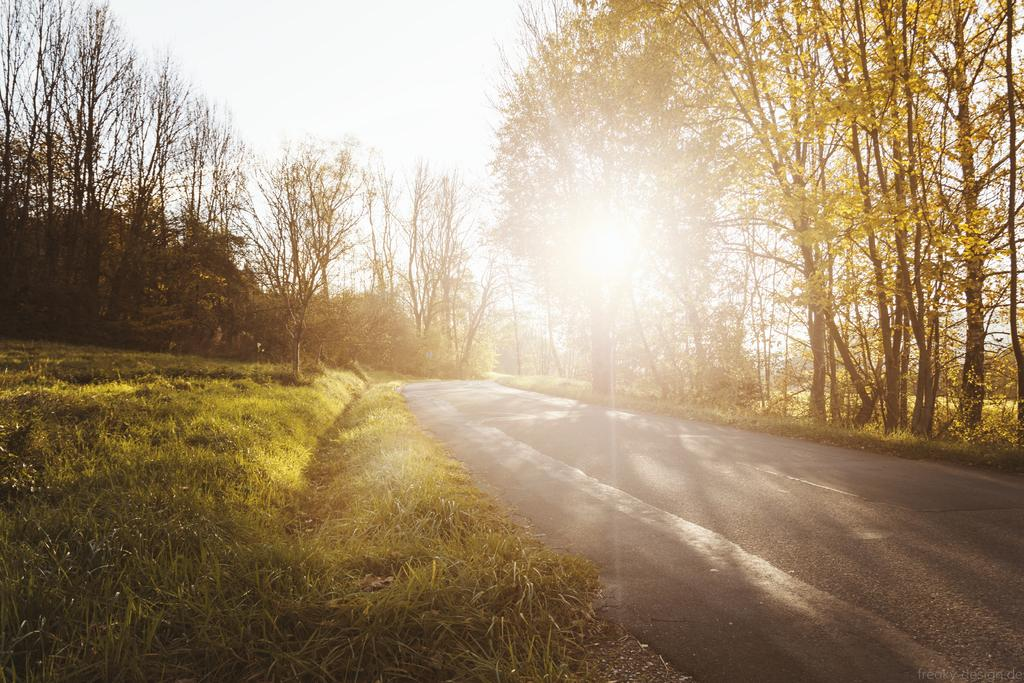What type of surface can be seen in the image? There is a road in the image. What covers the ground in the image? The ground is covered with grass. What type of vegetation is present in the image? There are plants and trees in the image. What is visible in the background of the image? The sky is visible in the image. What type of note is being played by the tree in the image? There is no note being played by a tree in the image, as trees do not produce musical notes. 